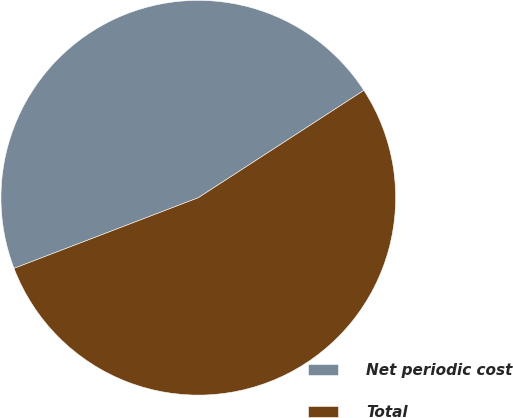<chart> <loc_0><loc_0><loc_500><loc_500><pie_chart><fcel>Net periodic cost<fcel>Total<nl><fcel>46.67%<fcel>53.33%<nl></chart> 